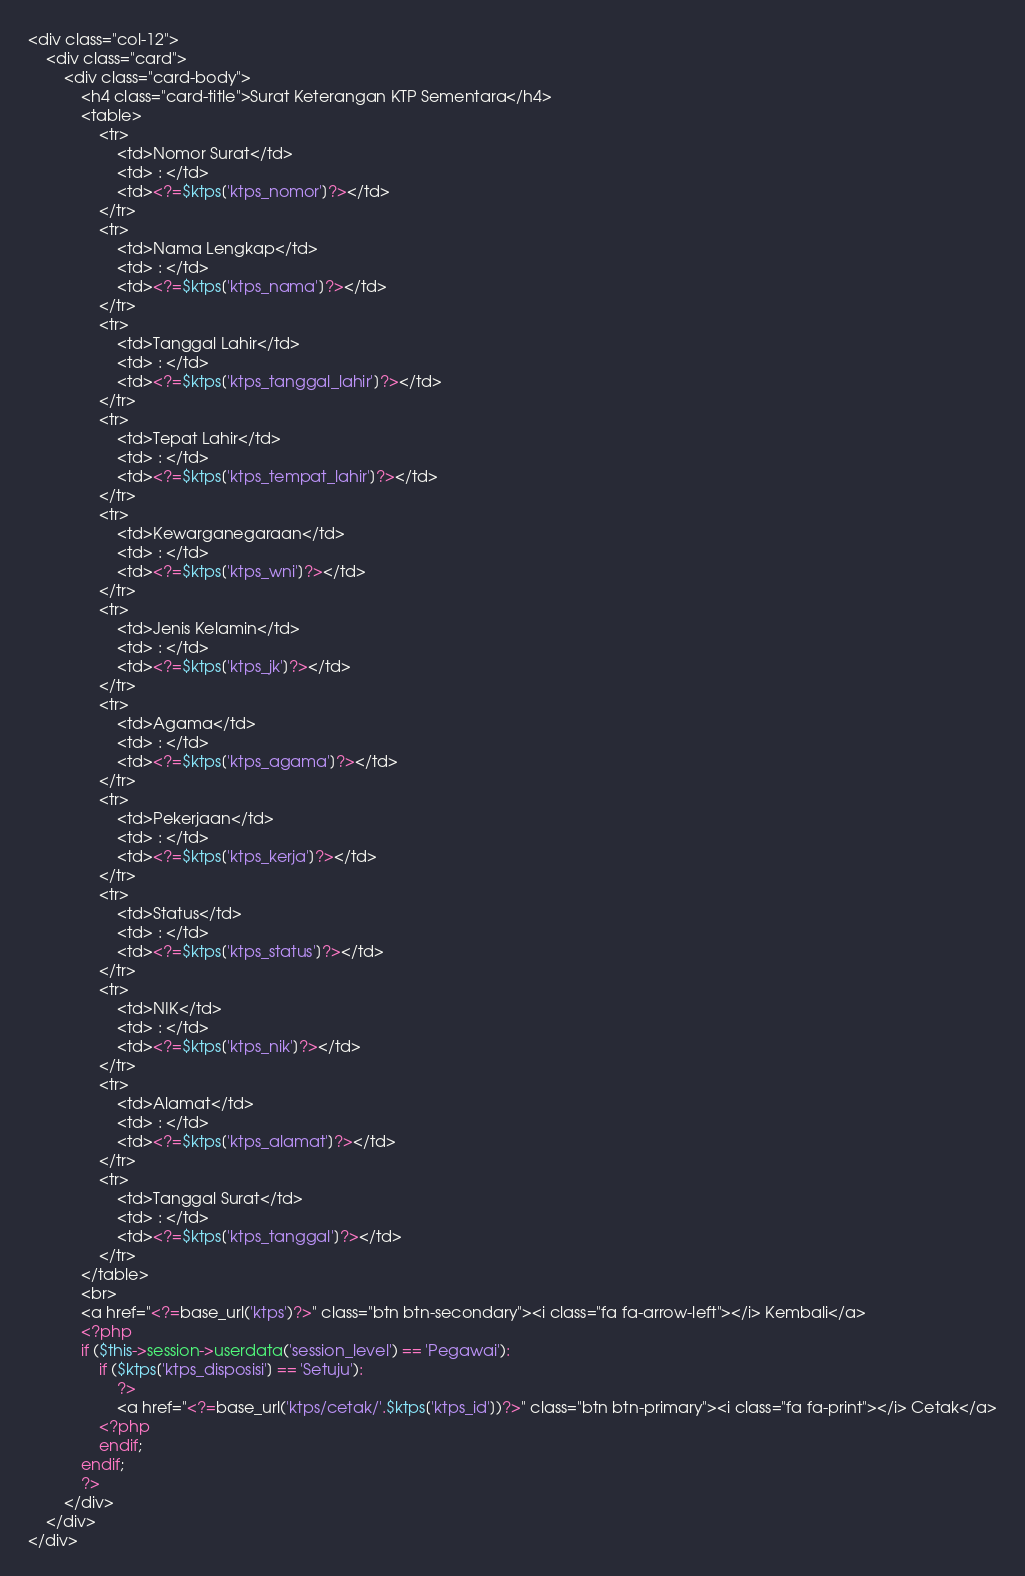<code> <loc_0><loc_0><loc_500><loc_500><_PHP_><div class="col-12">
	<div class="card">
		<div class="card-body">
			<h4 class="card-title">Surat Keterangan KTP Sementara</h4>
			<table>
				<tr>
					<td>Nomor Surat</td>
					<td> : </td>
					<td><?=$ktps['ktps_nomor']?></td>
				</tr>
				<tr>
					<td>Nama Lengkap</td>
					<td> : </td>
					<td><?=$ktps['ktps_nama']?></td>
				</tr>
				<tr>
					<td>Tanggal Lahir</td>
					<td> : </td>
					<td><?=$ktps['ktps_tanggal_lahir']?></td>
				</tr>
				<tr>
					<td>Tepat Lahir</td>
					<td> : </td>
					<td><?=$ktps['ktps_tempat_lahir']?></td>
				</tr>
				<tr>
					<td>Kewarganegaraan</td>
					<td> : </td>
					<td><?=$ktps['ktps_wni']?></td>
				</tr>
				<tr>
					<td>Jenis Kelamin</td>
					<td> : </td>
					<td><?=$ktps['ktps_jk']?></td>
				</tr>
				<tr>
					<td>Agama</td>
					<td> : </td>
					<td><?=$ktps['ktps_agama']?></td>
				</tr>
				<tr>
					<td>Pekerjaan</td>
					<td> : </td>
					<td><?=$ktps['ktps_kerja']?></td>
				</tr>
				<tr>
					<td>Status</td>
					<td> : </td>
					<td><?=$ktps['ktps_status']?></td>
				</tr>
				<tr>
					<td>NIK</td>
					<td> : </td>
					<td><?=$ktps['ktps_nik']?></td>
				</tr>
				<tr>
					<td>Alamat</td>
					<td> : </td>
					<td><?=$ktps['ktps_alamat']?></td>
				</tr>
				<tr>
					<td>Tanggal Surat</td>
					<td> : </td>
					<td><?=$ktps['ktps_tanggal']?></td>
				</tr>
			</table>
			<br>
			<a href="<?=base_url('ktps')?>" class="btn btn-secondary"><i class="fa fa-arrow-left"></i> Kembali</a>
			<?php
			if ($this->session->userdata('session_level') == 'Pegawai'):
				if ($ktps['ktps_disposisi'] == 'Setuju'):
					?>
					<a href="<?=base_url('ktps/cetak/'.$ktps['ktps_id'])?>" class="btn btn-primary"><i class="fa fa-print"></i> Cetak</a>
				<?php
				endif;
			endif;
			?>
		</div>
	</div>
</div>
</code> 